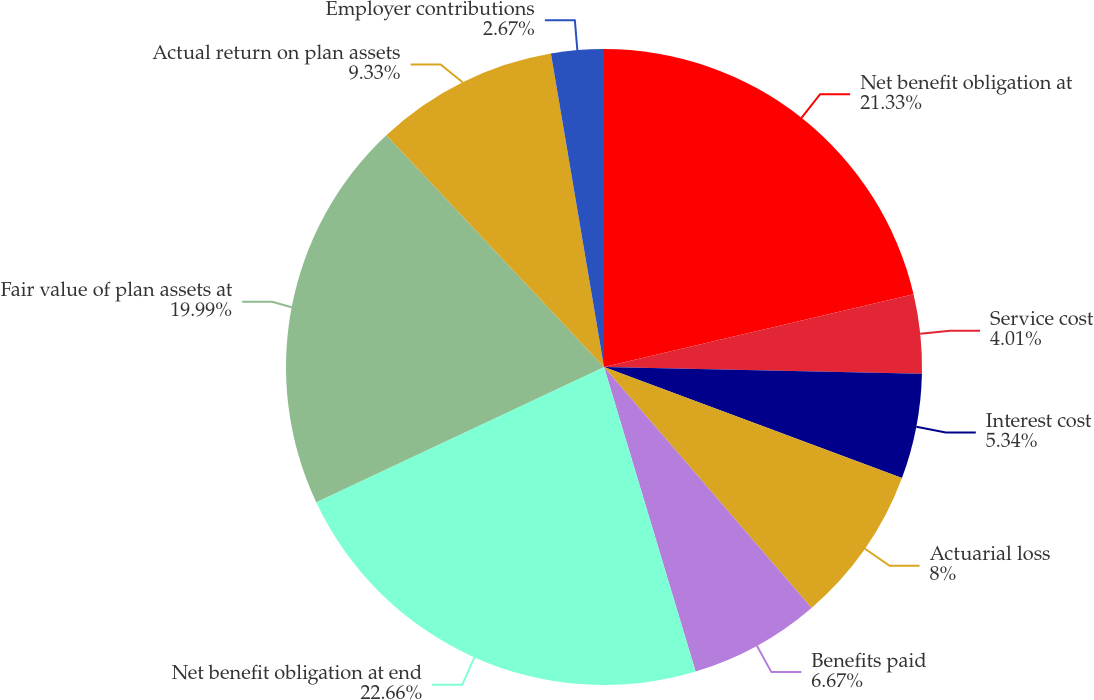Convert chart to OTSL. <chart><loc_0><loc_0><loc_500><loc_500><pie_chart><fcel>Net benefit obligation at<fcel>Service cost<fcel>Interest cost<fcel>Actuarial loss<fcel>Benefits paid<fcel>Net benefit obligation at end<fcel>Fair value of plan assets at<fcel>Actual return on plan assets<fcel>Employer contributions<nl><fcel>21.33%<fcel>4.01%<fcel>5.34%<fcel>8.0%<fcel>6.67%<fcel>22.66%<fcel>19.99%<fcel>9.33%<fcel>2.67%<nl></chart> 